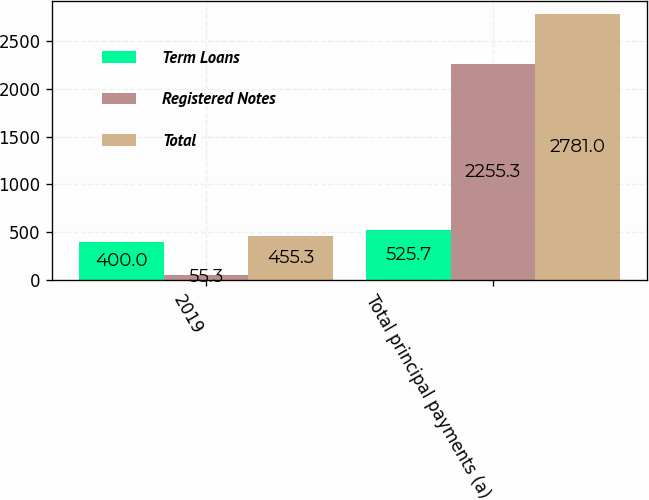Convert chart. <chart><loc_0><loc_0><loc_500><loc_500><stacked_bar_chart><ecel><fcel>2019<fcel>Total principal payments (a)<nl><fcel>Term Loans<fcel>400<fcel>525.7<nl><fcel>Registered Notes<fcel>55.3<fcel>2255.3<nl><fcel>Total<fcel>455.3<fcel>2781<nl></chart> 